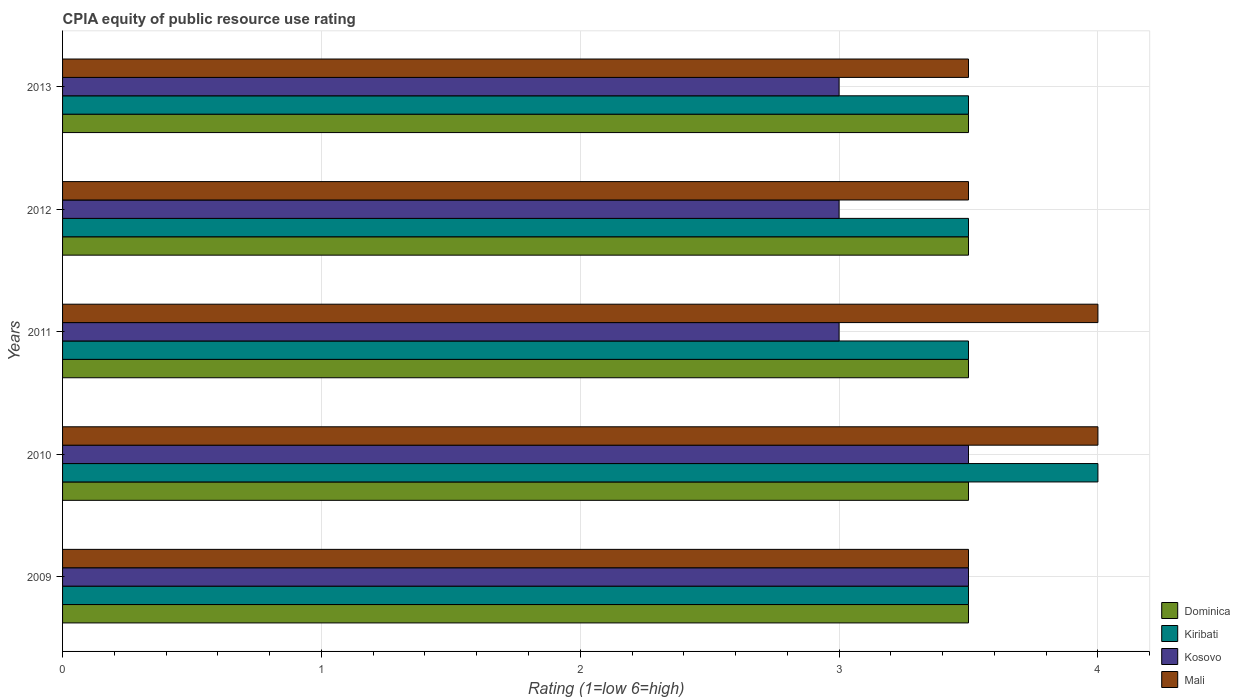How many different coloured bars are there?
Offer a terse response. 4. How many groups of bars are there?
Provide a succinct answer. 5. How many bars are there on the 1st tick from the top?
Offer a terse response. 4. How many bars are there on the 3rd tick from the bottom?
Provide a short and direct response. 4. In how many cases, is the number of bars for a given year not equal to the number of legend labels?
Your answer should be very brief. 0. What is the CPIA rating in Dominica in 2012?
Keep it short and to the point. 3.5. Across all years, what is the maximum CPIA rating in Kiribati?
Keep it short and to the point. 4. In which year was the CPIA rating in Mali maximum?
Provide a short and direct response. 2010. In which year was the CPIA rating in Kosovo minimum?
Provide a short and direct response. 2011. What is the average CPIA rating in Kosovo per year?
Keep it short and to the point. 3.2. In how many years, is the CPIA rating in Kiribati greater than 2.4 ?
Your answer should be very brief. 5. Is the CPIA rating in Mali in 2010 less than that in 2011?
Your answer should be compact. No. What does the 3rd bar from the top in 2013 represents?
Provide a succinct answer. Kiribati. What does the 2nd bar from the bottom in 2010 represents?
Provide a succinct answer. Kiribati. How many bars are there?
Your response must be concise. 20. Are all the bars in the graph horizontal?
Your response must be concise. Yes. Are the values on the major ticks of X-axis written in scientific E-notation?
Offer a terse response. No. Does the graph contain any zero values?
Your answer should be very brief. No. How many legend labels are there?
Provide a succinct answer. 4. What is the title of the graph?
Your response must be concise. CPIA equity of public resource use rating. Does "Marshall Islands" appear as one of the legend labels in the graph?
Give a very brief answer. No. What is the label or title of the Y-axis?
Your answer should be very brief. Years. What is the Rating (1=low 6=high) in Kiribati in 2009?
Offer a very short reply. 3.5. What is the Rating (1=low 6=high) of Mali in 2010?
Your response must be concise. 4. What is the Rating (1=low 6=high) of Kiribati in 2011?
Offer a terse response. 3.5. What is the Rating (1=low 6=high) of Dominica in 2012?
Provide a short and direct response. 3.5. What is the Rating (1=low 6=high) in Kiribati in 2012?
Your answer should be very brief. 3.5. What is the Rating (1=low 6=high) of Kiribati in 2013?
Provide a short and direct response. 3.5. Across all years, what is the maximum Rating (1=low 6=high) of Kosovo?
Your answer should be compact. 3.5. Across all years, what is the maximum Rating (1=low 6=high) in Mali?
Make the answer very short. 4. Across all years, what is the minimum Rating (1=low 6=high) of Kiribati?
Your answer should be very brief. 3.5. Across all years, what is the minimum Rating (1=low 6=high) in Kosovo?
Ensure brevity in your answer.  3. What is the total Rating (1=low 6=high) of Kosovo in the graph?
Provide a succinct answer. 16. What is the difference between the Rating (1=low 6=high) of Dominica in 2009 and that in 2010?
Give a very brief answer. 0. What is the difference between the Rating (1=low 6=high) of Kosovo in 2009 and that in 2010?
Your answer should be very brief. 0. What is the difference between the Rating (1=low 6=high) of Mali in 2009 and that in 2010?
Offer a terse response. -0.5. What is the difference between the Rating (1=low 6=high) of Dominica in 2009 and that in 2011?
Your answer should be very brief. 0. What is the difference between the Rating (1=low 6=high) of Dominica in 2009 and that in 2012?
Provide a short and direct response. 0. What is the difference between the Rating (1=low 6=high) in Kosovo in 2009 and that in 2012?
Your response must be concise. 0.5. What is the difference between the Rating (1=low 6=high) in Kiribati in 2009 and that in 2013?
Your answer should be very brief. 0. What is the difference between the Rating (1=low 6=high) of Kosovo in 2009 and that in 2013?
Ensure brevity in your answer.  0.5. What is the difference between the Rating (1=low 6=high) in Mali in 2009 and that in 2013?
Offer a very short reply. 0. What is the difference between the Rating (1=low 6=high) in Dominica in 2010 and that in 2011?
Offer a very short reply. 0. What is the difference between the Rating (1=low 6=high) in Kosovo in 2010 and that in 2011?
Your answer should be very brief. 0.5. What is the difference between the Rating (1=low 6=high) of Kiribati in 2010 and that in 2012?
Make the answer very short. 0.5. What is the difference between the Rating (1=low 6=high) of Kosovo in 2010 and that in 2012?
Ensure brevity in your answer.  0.5. What is the difference between the Rating (1=low 6=high) of Dominica in 2010 and that in 2013?
Ensure brevity in your answer.  0. What is the difference between the Rating (1=low 6=high) in Kosovo in 2011 and that in 2012?
Your answer should be compact. 0. What is the difference between the Rating (1=low 6=high) of Kiribati in 2011 and that in 2013?
Provide a succinct answer. 0. What is the difference between the Rating (1=low 6=high) in Mali in 2011 and that in 2013?
Give a very brief answer. 0.5. What is the difference between the Rating (1=low 6=high) of Dominica in 2012 and that in 2013?
Provide a short and direct response. 0. What is the difference between the Rating (1=low 6=high) in Kiribati in 2012 and that in 2013?
Keep it short and to the point. 0. What is the difference between the Rating (1=low 6=high) of Kosovo in 2012 and that in 2013?
Make the answer very short. 0. What is the difference between the Rating (1=low 6=high) in Dominica in 2009 and the Rating (1=low 6=high) in Mali in 2010?
Provide a short and direct response. -0.5. What is the difference between the Rating (1=low 6=high) of Kiribati in 2009 and the Rating (1=low 6=high) of Kosovo in 2010?
Your answer should be compact. 0. What is the difference between the Rating (1=low 6=high) of Kosovo in 2009 and the Rating (1=low 6=high) of Mali in 2010?
Your answer should be compact. -0.5. What is the difference between the Rating (1=low 6=high) in Dominica in 2009 and the Rating (1=low 6=high) in Kiribati in 2011?
Your answer should be compact. 0. What is the difference between the Rating (1=low 6=high) in Dominica in 2009 and the Rating (1=low 6=high) in Kosovo in 2011?
Keep it short and to the point. 0.5. What is the difference between the Rating (1=low 6=high) of Kiribati in 2009 and the Rating (1=low 6=high) of Kosovo in 2011?
Provide a succinct answer. 0.5. What is the difference between the Rating (1=low 6=high) of Kosovo in 2009 and the Rating (1=low 6=high) of Mali in 2011?
Offer a very short reply. -0.5. What is the difference between the Rating (1=low 6=high) of Dominica in 2009 and the Rating (1=low 6=high) of Kiribati in 2012?
Offer a terse response. 0. What is the difference between the Rating (1=low 6=high) in Dominica in 2009 and the Rating (1=low 6=high) in Mali in 2012?
Your answer should be compact. 0. What is the difference between the Rating (1=low 6=high) of Kosovo in 2009 and the Rating (1=low 6=high) of Mali in 2012?
Provide a short and direct response. 0. What is the difference between the Rating (1=low 6=high) in Dominica in 2009 and the Rating (1=low 6=high) in Kiribati in 2013?
Give a very brief answer. 0. What is the difference between the Rating (1=low 6=high) in Kiribati in 2009 and the Rating (1=low 6=high) in Kosovo in 2013?
Your answer should be compact. 0.5. What is the difference between the Rating (1=low 6=high) of Dominica in 2010 and the Rating (1=low 6=high) of Kosovo in 2011?
Give a very brief answer. 0.5. What is the difference between the Rating (1=low 6=high) in Kiribati in 2010 and the Rating (1=low 6=high) in Mali in 2011?
Your answer should be compact. 0. What is the difference between the Rating (1=low 6=high) of Kosovo in 2010 and the Rating (1=low 6=high) of Mali in 2011?
Offer a very short reply. -0.5. What is the difference between the Rating (1=low 6=high) of Dominica in 2010 and the Rating (1=low 6=high) of Kosovo in 2012?
Your answer should be compact. 0.5. What is the difference between the Rating (1=low 6=high) of Kiribati in 2010 and the Rating (1=low 6=high) of Kosovo in 2012?
Offer a very short reply. 1. What is the difference between the Rating (1=low 6=high) in Kiribati in 2010 and the Rating (1=low 6=high) in Mali in 2012?
Provide a short and direct response. 0.5. What is the difference between the Rating (1=low 6=high) of Dominica in 2010 and the Rating (1=low 6=high) of Kosovo in 2013?
Ensure brevity in your answer.  0.5. What is the difference between the Rating (1=low 6=high) in Kiribati in 2010 and the Rating (1=low 6=high) in Mali in 2013?
Ensure brevity in your answer.  0.5. What is the difference between the Rating (1=low 6=high) in Dominica in 2011 and the Rating (1=low 6=high) in Kosovo in 2012?
Make the answer very short. 0.5. What is the difference between the Rating (1=low 6=high) in Kiribati in 2011 and the Rating (1=low 6=high) in Mali in 2012?
Your answer should be compact. 0. What is the difference between the Rating (1=low 6=high) of Dominica in 2011 and the Rating (1=low 6=high) of Kiribati in 2013?
Your answer should be very brief. 0. What is the difference between the Rating (1=low 6=high) in Dominica in 2011 and the Rating (1=low 6=high) in Mali in 2013?
Offer a very short reply. 0. What is the difference between the Rating (1=low 6=high) of Kiribati in 2011 and the Rating (1=low 6=high) of Mali in 2013?
Provide a succinct answer. 0. What is the difference between the Rating (1=low 6=high) in Dominica in 2012 and the Rating (1=low 6=high) in Kiribati in 2013?
Your response must be concise. 0. What is the difference between the Rating (1=low 6=high) in Dominica in 2012 and the Rating (1=low 6=high) in Kosovo in 2013?
Offer a terse response. 0.5. What is the difference between the Rating (1=low 6=high) in Kiribati in 2012 and the Rating (1=low 6=high) in Kosovo in 2013?
Your answer should be very brief. 0.5. What is the difference between the Rating (1=low 6=high) of Kiribati in 2012 and the Rating (1=low 6=high) of Mali in 2013?
Provide a succinct answer. 0. What is the difference between the Rating (1=low 6=high) of Kosovo in 2012 and the Rating (1=low 6=high) of Mali in 2013?
Ensure brevity in your answer.  -0.5. What is the average Rating (1=low 6=high) of Kosovo per year?
Ensure brevity in your answer.  3.2. What is the average Rating (1=low 6=high) in Mali per year?
Provide a short and direct response. 3.7. In the year 2009, what is the difference between the Rating (1=low 6=high) in Kiribati and Rating (1=low 6=high) in Kosovo?
Offer a very short reply. 0. In the year 2009, what is the difference between the Rating (1=low 6=high) of Kiribati and Rating (1=low 6=high) of Mali?
Your response must be concise. 0. In the year 2010, what is the difference between the Rating (1=low 6=high) of Dominica and Rating (1=low 6=high) of Kiribati?
Keep it short and to the point. -0.5. In the year 2010, what is the difference between the Rating (1=low 6=high) in Dominica and Rating (1=low 6=high) in Kosovo?
Make the answer very short. 0. In the year 2010, what is the difference between the Rating (1=low 6=high) of Kiribati and Rating (1=low 6=high) of Kosovo?
Keep it short and to the point. 0.5. In the year 2010, what is the difference between the Rating (1=low 6=high) of Kiribati and Rating (1=low 6=high) of Mali?
Offer a terse response. 0. In the year 2010, what is the difference between the Rating (1=low 6=high) in Kosovo and Rating (1=low 6=high) in Mali?
Your answer should be very brief. -0.5. In the year 2011, what is the difference between the Rating (1=low 6=high) of Dominica and Rating (1=low 6=high) of Kiribati?
Provide a short and direct response. 0. In the year 2011, what is the difference between the Rating (1=low 6=high) of Dominica and Rating (1=low 6=high) of Mali?
Keep it short and to the point. -0.5. In the year 2011, what is the difference between the Rating (1=low 6=high) in Kiribati and Rating (1=low 6=high) in Mali?
Keep it short and to the point. -0.5. In the year 2012, what is the difference between the Rating (1=low 6=high) of Dominica and Rating (1=low 6=high) of Kosovo?
Ensure brevity in your answer.  0.5. In the year 2012, what is the difference between the Rating (1=low 6=high) in Kiribati and Rating (1=low 6=high) in Kosovo?
Ensure brevity in your answer.  0.5. In the year 2012, what is the difference between the Rating (1=low 6=high) of Kiribati and Rating (1=low 6=high) of Mali?
Provide a succinct answer. 0. In the year 2013, what is the difference between the Rating (1=low 6=high) in Dominica and Rating (1=low 6=high) in Kiribati?
Provide a short and direct response. 0. In the year 2013, what is the difference between the Rating (1=low 6=high) in Kiribati and Rating (1=low 6=high) in Kosovo?
Provide a succinct answer. 0.5. In the year 2013, what is the difference between the Rating (1=low 6=high) of Kiribati and Rating (1=low 6=high) of Mali?
Offer a very short reply. 0. In the year 2013, what is the difference between the Rating (1=low 6=high) in Kosovo and Rating (1=low 6=high) in Mali?
Keep it short and to the point. -0.5. What is the ratio of the Rating (1=low 6=high) in Dominica in 2009 to that in 2010?
Provide a succinct answer. 1. What is the ratio of the Rating (1=low 6=high) in Kosovo in 2009 to that in 2010?
Your answer should be compact. 1. What is the ratio of the Rating (1=low 6=high) of Mali in 2009 to that in 2010?
Your response must be concise. 0.88. What is the ratio of the Rating (1=low 6=high) in Dominica in 2009 to that in 2011?
Ensure brevity in your answer.  1. What is the ratio of the Rating (1=low 6=high) of Kiribati in 2009 to that in 2011?
Offer a very short reply. 1. What is the ratio of the Rating (1=low 6=high) of Kosovo in 2009 to that in 2011?
Keep it short and to the point. 1.17. What is the ratio of the Rating (1=low 6=high) of Mali in 2009 to that in 2011?
Provide a succinct answer. 0.88. What is the ratio of the Rating (1=low 6=high) of Dominica in 2009 to that in 2012?
Your answer should be compact. 1. What is the ratio of the Rating (1=low 6=high) in Kosovo in 2009 to that in 2012?
Make the answer very short. 1.17. What is the ratio of the Rating (1=low 6=high) of Mali in 2009 to that in 2012?
Provide a succinct answer. 1. What is the ratio of the Rating (1=low 6=high) of Dominica in 2009 to that in 2013?
Provide a succinct answer. 1. What is the ratio of the Rating (1=low 6=high) in Kiribati in 2009 to that in 2013?
Offer a very short reply. 1. What is the ratio of the Rating (1=low 6=high) of Kosovo in 2009 to that in 2013?
Your answer should be very brief. 1.17. What is the ratio of the Rating (1=low 6=high) of Mali in 2009 to that in 2013?
Your answer should be compact. 1. What is the ratio of the Rating (1=low 6=high) in Mali in 2010 to that in 2011?
Give a very brief answer. 1. What is the ratio of the Rating (1=low 6=high) in Dominica in 2010 to that in 2012?
Your answer should be very brief. 1. What is the ratio of the Rating (1=low 6=high) of Mali in 2010 to that in 2012?
Your answer should be very brief. 1.14. What is the ratio of the Rating (1=low 6=high) of Dominica in 2010 to that in 2013?
Your response must be concise. 1. What is the ratio of the Rating (1=low 6=high) of Kiribati in 2010 to that in 2013?
Offer a terse response. 1.14. What is the ratio of the Rating (1=low 6=high) of Kosovo in 2010 to that in 2013?
Ensure brevity in your answer.  1.17. What is the ratio of the Rating (1=low 6=high) of Kiribati in 2011 to that in 2012?
Your response must be concise. 1. What is the ratio of the Rating (1=low 6=high) in Mali in 2011 to that in 2012?
Provide a succinct answer. 1.14. What is the ratio of the Rating (1=low 6=high) of Dominica in 2011 to that in 2013?
Ensure brevity in your answer.  1. What is the ratio of the Rating (1=low 6=high) in Kosovo in 2011 to that in 2013?
Your answer should be very brief. 1. What is the ratio of the Rating (1=low 6=high) in Mali in 2011 to that in 2013?
Provide a short and direct response. 1.14. What is the ratio of the Rating (1=low 6=high) of Kiribati in 2012 to that in 2013?
Offer a very short reply. 1. What is the ratio of the Rating (1=low 6=high) of Mali in 2012 to that in 2013?
Offer a very short reply. 1. What is the difference between the highest and the second highest Rating (1=low 6=high) in Dominica?
Provide a succinct answer. 0. What is the difference between the highest and the second highest Rating (1=low 6=high) of Kiribati?
Provide a succinct answer. 0.5. What is the difference between the highest and the second highest Rating (1=low 6=high) of Kosovo?
Provide a short and direct response. 0. What is the difference between the highest and the lowest Rating (1=low 6=high) of Dominica?
Your answer should be compact. 0. What is the difference between the highest and the lowest Rating (1=low 6=high) in Kosovo?
Keep it short and to the point. 0.5. What is the difference between the highest and the lowest Rating (1=low 6=high) in Mali?
Provide a succinct answer. 0.5. 